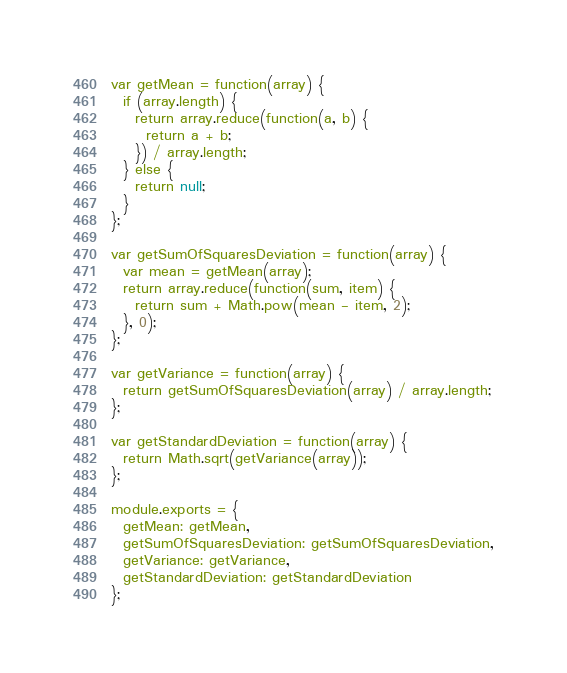<code> <loc_0><loc_0><loc_500><loc_500><_JavaScript_>var getMean = function(array) {
  if (array.length) {
    return array.reduce(function(a, b) {
      return a + b;
    }) / array.length;
  } else {
    return null;
  }
};

var getSumOfSquaresDeviation = function(array) {
  var mean = getMean(array);
  return array.reduce(function(sum, item) {
    return sum + Math.pow(mean - item, 2);
  }, 0);
};

var getVariance = function(array) {
  return getSumOfSquaresDeviation(array) / array.length;
};

var getStandardDeviation = function(array) {
  return Math.sqrt(getVariance(array));
};

module.exports = {
  getMean: getMean,
  getSumOfSquaresDeviation: getSumOfSquaresDeviation,
  getVariance: getVariance,
  getStandardDeviation: getStandardDeviation
};
</code> 